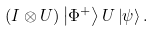<formula> <loc_0><loc_0><loc_500><loc_500>( I \otimes U ) \left | \Phi ^ { + } \right \rangle U \left | \psi \right \rangle .</formula> 